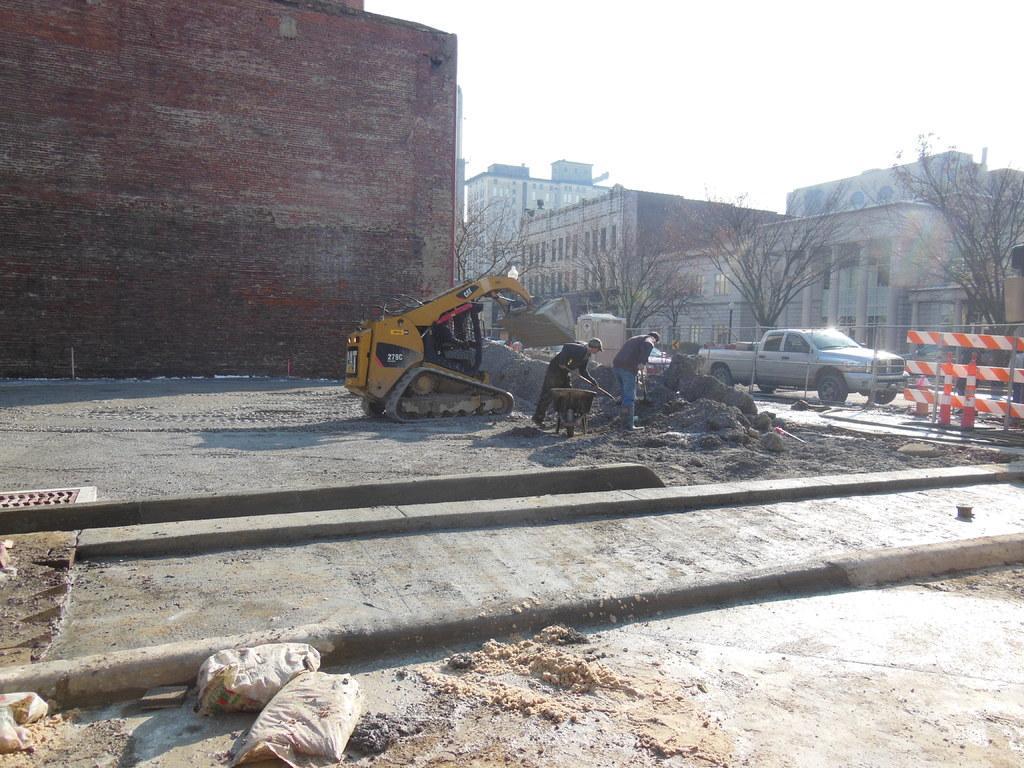In one or two sentences, can you explain what this image depicts? In the foreground of this image, there is sand and few bags on the ground. In the middle, there is a crane, two men holding shovel and an object on the ground. In the background, there are buildings, trees and the sky. On the right, there is a barrier board and a vehicle on the road. 